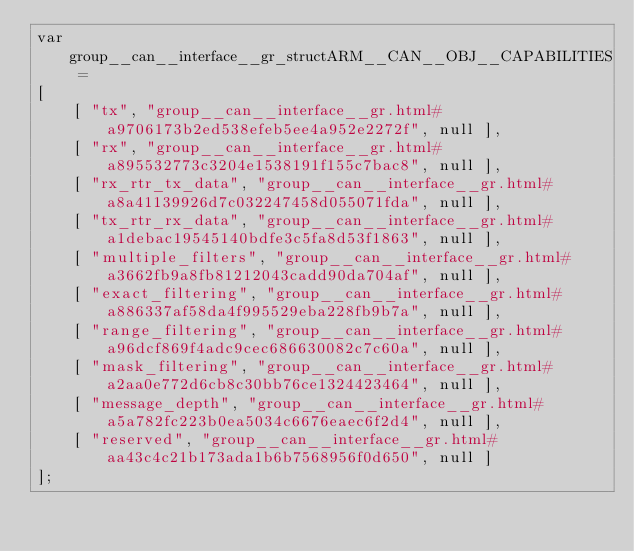<code> <loc_0><loc_0><loc_500><loc_500><_JavaScript_>var group__can__interface__gr_structARM__CAN__OBJ__CAPABILITIES =
[
    [ "tx", "group__can__interface__gr.html#a9706173b2ed538efeb5ee4a952e2272f", null ],
    [ "rx", "group__can__interface__gr.html#a895532773c3204e1538191f155c7bac8", null ],
    [ "rx_rtr_tx_data", "group__can__interface__gr.html#a8a41139926d7c032247458d055071fda", null ],
    [ "tx_rtr_rx_data", "group__can__interface__gr.html#a1debac19545140bdfe3c5fa8d53f1863", null ],
    [ "multiple_filters", "group__can__interface__gr.html#a3662fb9a8fb81212043cadd90da704af", null ],
    [ "exact_filtering", "group__can__interface__gr.html#a886337af58da4f995529eba228fb9b7a", null ],
    [ "range_filtering", "group__can__interface__gr.html#a96dcf869f4adc9cec686630082c7c60a", null ],
    [ "mask_filtering", "group__can__interface__gr.html#a2aa0e772d6cb8c30bb76ce1324423464", null ],
    [ "message_depth", "group__can__interface__gr.html#a5a782fc223b0ea5034c6676eaec6f2d4", null ],
    [ "reserved", "group__can__interface__gr.html#aa43c4c21b173ada1b6b7568956f0d650", null ]
];</code> 